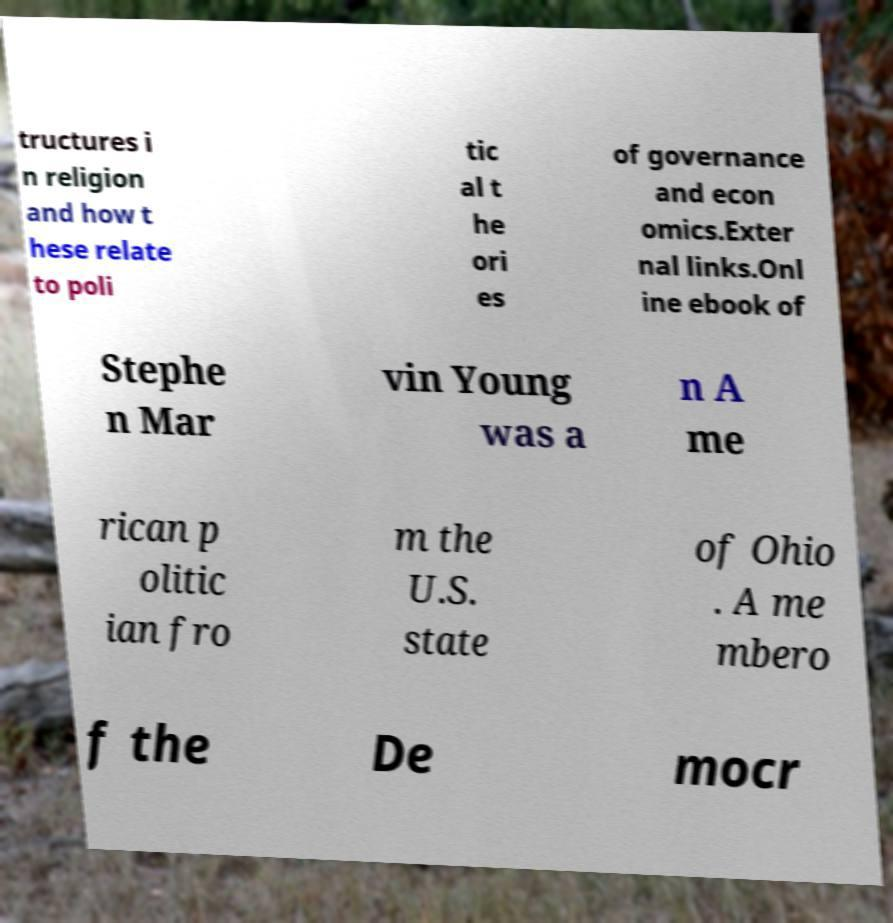For documentation purposes, I need the text within this image transcribed. Could you provide that? tructures i n religion and how t hese relate to poli tic al t he ori es of governance and econ omics.Exter nal links.Onl ine ebook of Stephe n Mar vin Young was a n A me rican p olitic ian fro m the U.S. state of Ohio . A me mbero f the De mocr 